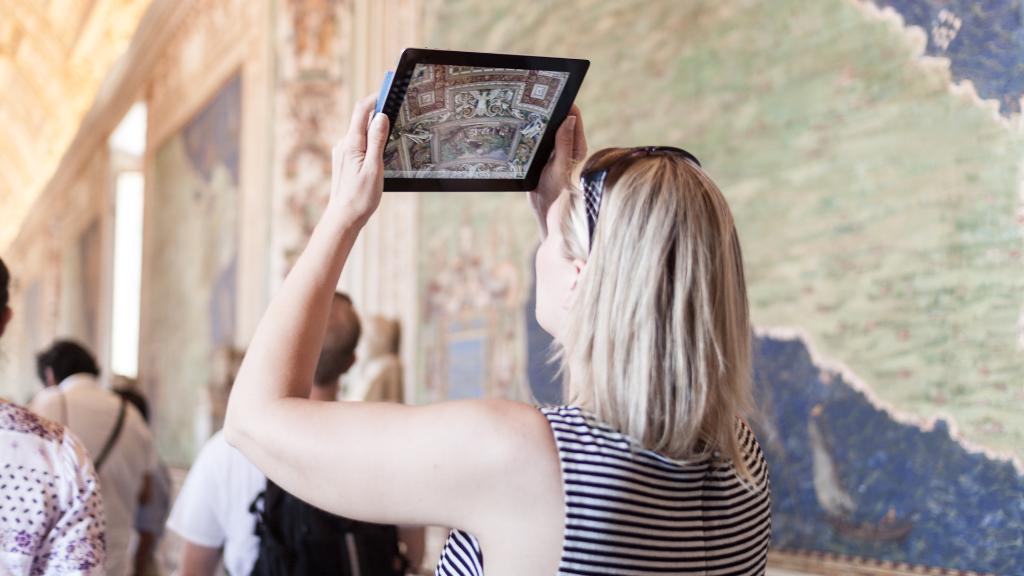Please provide a concise description of this image. In this picture there is a lady in the center of the image, by holding a tab in her hands and there are other people in front of her and there are designed walls in the image. 